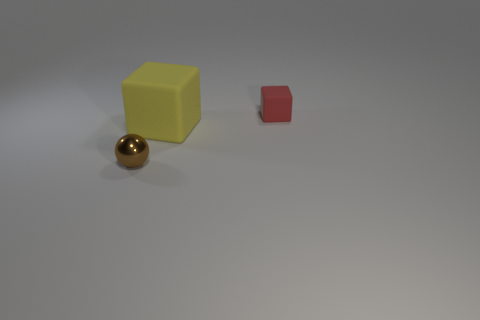Are there any other things that are the same material as the tiny brown ball?
Offer a terse response. No. Is there any other thing that has the same size as the yellow cube?
Make the answer very short. No. Does the tiny rubber cube have the same color as the thing left of the big block?
Your answer should be very brief. No. The shiny object is what color?
Your response must be concise. Brown. Are there any other things that have the same shape as the tiny red thing?
Offer a very short reply. Yes. What is the color of the other matte thing that is the same shape as the red rubber object?
Keep it short and to the point. Yellow. Is the small brown shiny thing the same shape as the small red object?
Provide a succinct answer. No. How many balls are small shiny objects or red rubber things?
Give a very brief answer. 1. The other object that is the same material as the big object is what color?
Offer a very short reply. Red. Is the size of the rubber object in front of the red rubber block the same as the small brown ball?
Provide a succinct answer. No. 